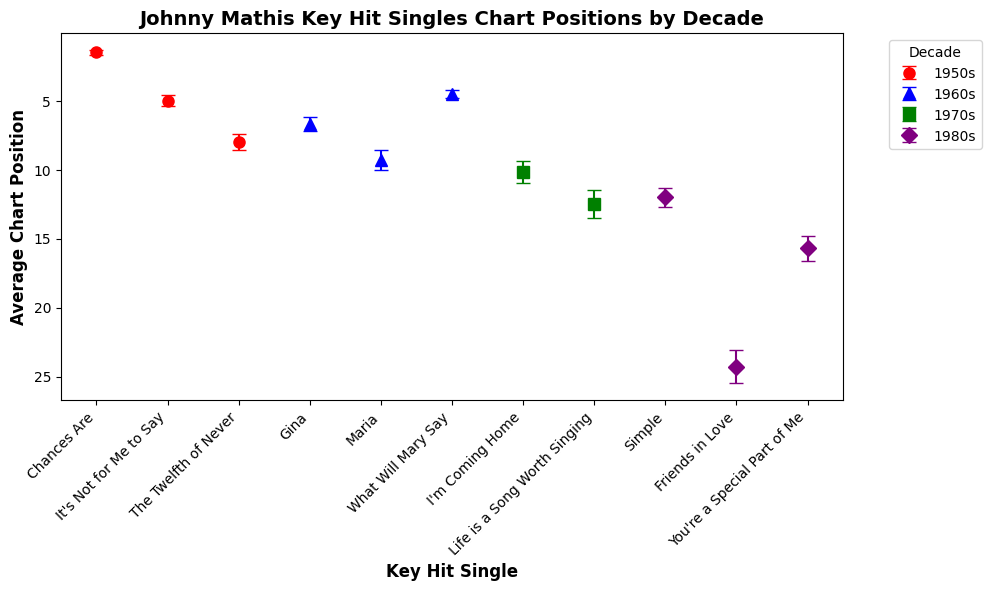Which song in the 1950s had the highest average chart position? Look at the 1950s data points and identify which song has the lowest (highest on the charts) value on the y-axis. 'Chances Are' has the lowest average chart position of 1.5.
Answer: 'Chances Are' Regarding the 1960s, how does 'Maria' compare to 'What Will Mary Say' in terms of average chart position? Compare the chart positions of 'Maria' and 'What Will Mary Say' from the 1960s. 'Maria' has an average chart position of 9.3 while 'What Will Mary Say' has 4.5. 'What Will Mary Say' charted better.
Answer: 'What Will Mary Say' charted better What is the difference in average chart position between 'I'm Coming Home' and 'Life is a Song Worth Singing' from the 1970s? Find the average chart positions of both songs and calculate their difference. 'I'm Coming Home' has a position of 10.2, and 'Life is a Song Worth Singing' has 12.5. The difference is 12.5 - 10.2 = 2.3.
Answer: 2.3 Which decade saw the song with the worst (highest value) average chart position among the visible data points? Compare the highest values of average chart positions across all decades. 'Friends in Love' from the 1980s has an average position of 24.3, which is the highest visible value.
Answer: 1980s Which song from the 1980s has a better average chart position: 'Simple' or 'You're a Special Part of Me'? Compare the average chart positions of 'Simple' and 'You're a Special Part of Me' from the 1980s. 'Simple' has a position of 12.0, and 'You're a Special Part of Me' has 15.7. 'Simple' performed better.
Answer: 'Simple' What is the combined average chart position for the three 1950s hits: 'Chances Are', 'It's Not for Me to Say', and 'The Twelfth of Never'? Add their average chart positions and find the total. 'Chances Are' has 1.5, 'It's Not for Me to Say' has 5.0, and 'The Twelfth of Never' has 8.0. Their total is 1.5 + 5.0 + 8.0 = 14.5.
Answer: 14.5 How does the error estimate for 'Gina' in the 1960s compare to 'The Twelfth of Never' in the 1950s? Compare the error estimates for each song. 'Gina' has an error estimate of 0.5, and 'The Twelfth of Never' has an error estimate of 0.6. 'Gina' has a smaller error estimate.
Answer: 'Gina' has a smaller error estimate Which decade has the least variation (smallest error estimate) in chart positions among its hits according to the data? Evaluate the error estimates of each decade and identify the smallest. The 1950s have error estimates of 0.2, 0.4, and 0.6, with the smallest being 0.2.
Answer: 1950s Among the songs 'What Will Mary Say' and 'Life is a Song Worth Singing', which one had a more precise chart performance judging by the error estimates? 'What Will Mary Say' has an error estimate of 0.3 and 'Life is a Song Worth Singing' has 1.0. The smaller the error estimate, the more precise.
Answer: 'What Will Mary Say' 